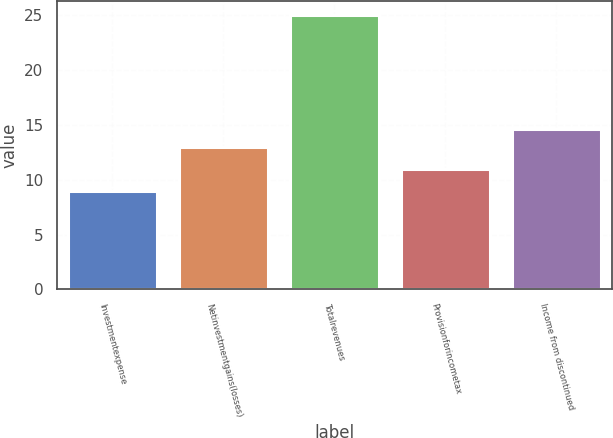Convert chart. <chart><loc_0><loc_0><loc_500><loc_500><bar_chart><fcel>Investmentexpense<fcel>Netinvestmentgains(losses)<fcel>Totalrevenues<fcel>Provisionforincometax<fcel>Income from discontinued<nl><fcel>9<fcel>13<fcel>25<fcel>11<fcel>14.6<nl></chart> 